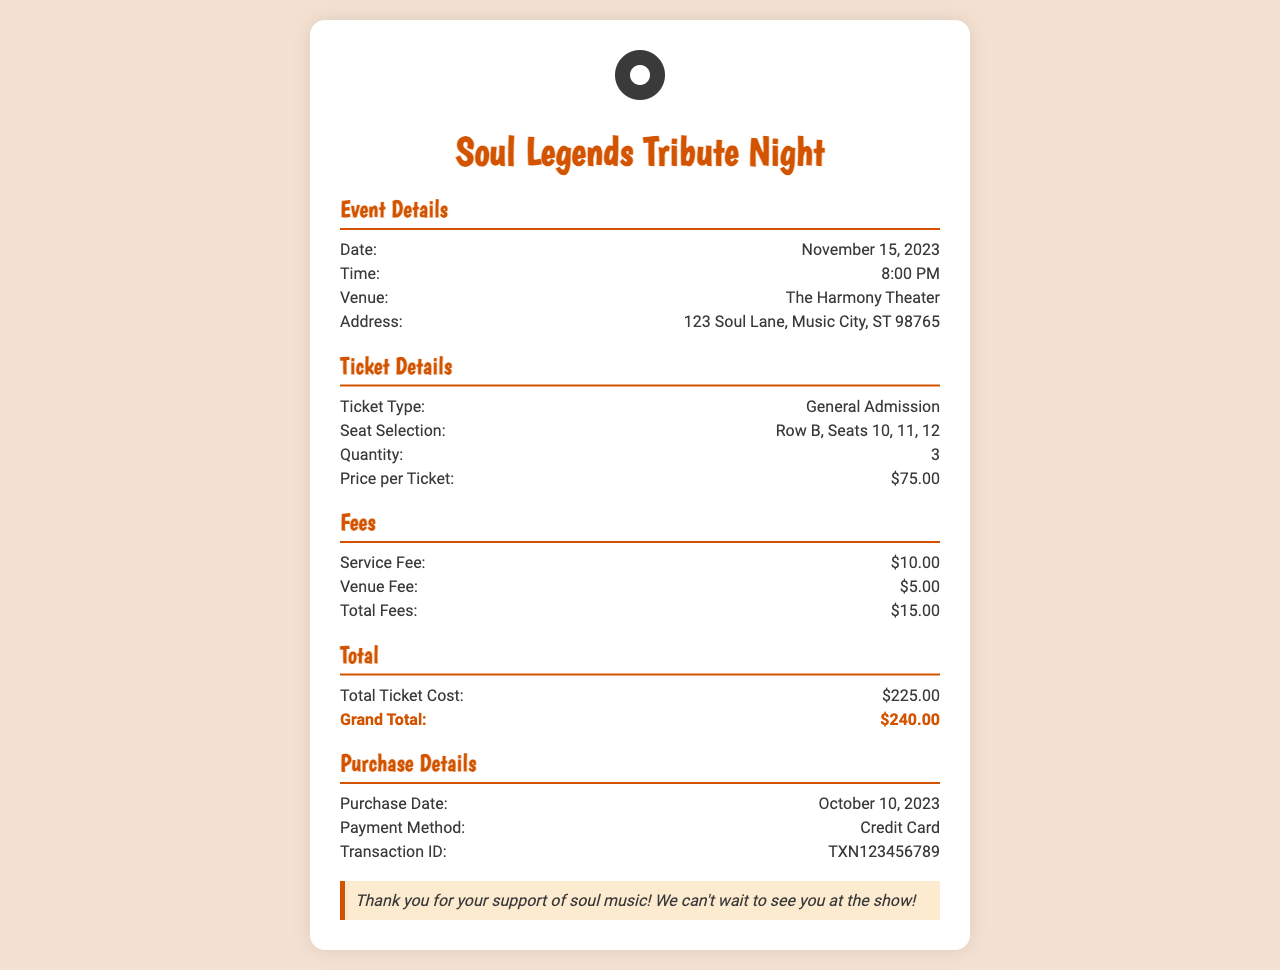what is the date of the event? The event date is specified in the document, which is November 15, 2023.
Answer: November 15, 2023 what is the venue name? The venue name is provided in the event details section of the document.
Answer: The Harmony Theater how much is the service fee? The document explicitly lists the service fee amount, which is $10.00.
Answer: $10.00 how many tickets were purchased? The quantity of tickets is mentioned in the ticket details section, which is 3.
Answer: 3 what is the grand total? The grand total is calculated from the total ticket cost and fees outlined in the document.
Answer: $240.00 what is the time of the event? The event time is provided in the document, which is 8:00 PM.
Answer: 8:00 PM what seats were selected? The seat selection is detailed in the ticket details section, listing the specific seats chosen.
Answer: Row B, Seats 10, 11, 12 when was the purchase made? The purchase date is mentioned under the purchase details in the document.
Answer: October 10, 2023 what payment method was used? The payment method is specified in the document, under the purchase details section.
Answer: Credit Card 